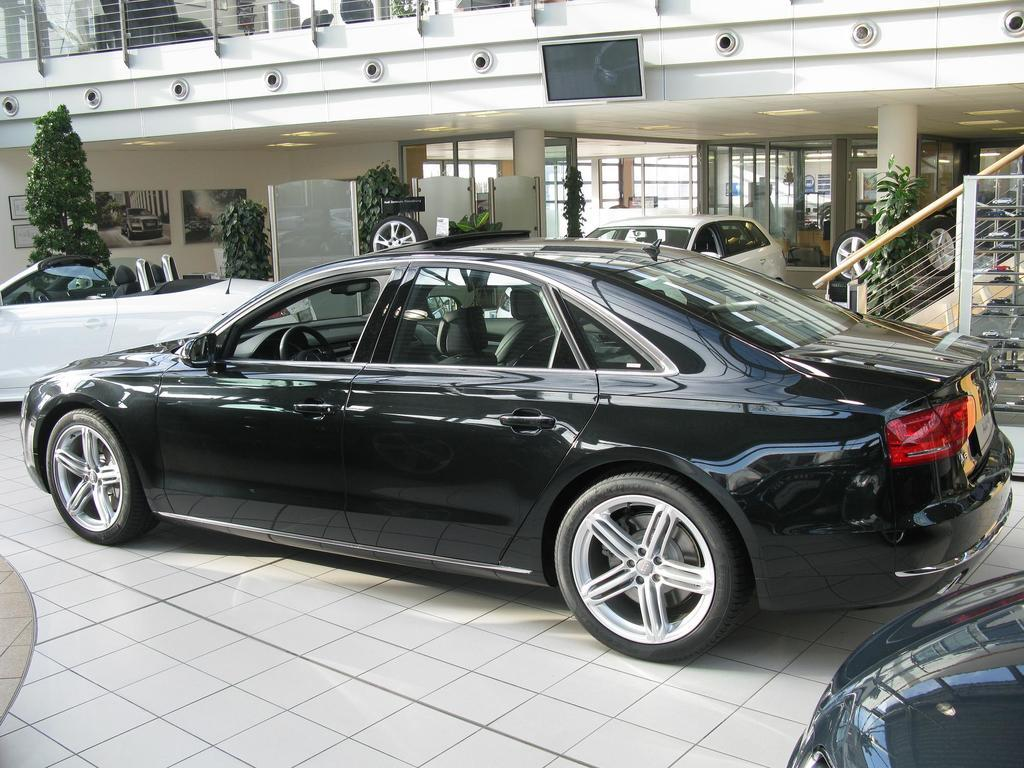What type of vehicles can be seen in the image? There are cars in the image. What is located beside the cars? There are plants beside the cars. What material are the rods made of in the image? Metal rods are present in the image. What type of structure can be seen in the image? There is a building in the image. What type of growth can be seen on the cars in the image? There is no growth visible on the cars in the image. What is being served for breakfast in the image? There is no indication of breakfast in the image. 